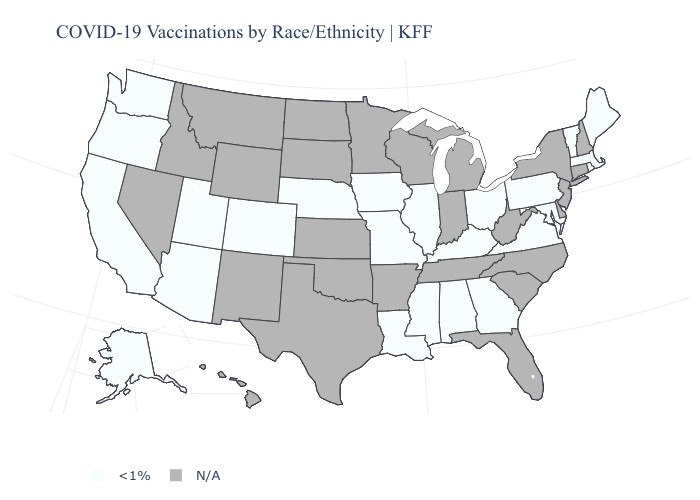Does the first symbol in the legend represent the smallest category?
Write a very short answer. Yes. What is the value of California?
Quick response, please. <1%. Name the states that have a value in the range N/A?
Keep it brief. Arkansas, Connecticut, Delaware, Florida, Hawaii, Idaho, Indiana, Kansas, Michigan, Minnesota, Montana, Nevada, New Hampshire, New Jersey, New Mexico, New York, North Carolina, North Dakota, Oklahoma, South Carolina, South Dakota, Tennessee, Texas, West Virginia, Wisconsin, Wyoming. What is the value of Virginia?
Short answer required. <1%. What is the lowest value in states that border Georgia?
Keep it brief. <1%. Name the states that have a value in the range N/A?
Write a very short answer. Arkansas, Connecticut, Delaware, Florida, Hawaii, Idaho, Indiana, Kansas, Michigan, Minnesota, Montana, Nevada, New Hampshire, New Jersey, New Mexico, New York, North Carolina, North Dakota, Oklahoma, South Carolina, South Dakota, Tennessee, Texas, West Virginia, Wisconsin, Wyoming. Which states hav the highest value in the South?
Give a very brief answer. Alabama, Georgia, Kentucky, Louisiana, Maryland, Mississippi, Virginia. What is the lowest value in the USA?
Keep it brief. <1%. What is the highest value in states that border New Mexico?
Answer briefly. <1%. Name the states that have a value in the range <1%?
Keep it brief. Alabama, Alaska, Arizona, California, Colorado, Georgia, Illinois, Iowa, Kentucky, Louisiana, Maine, Maryland, Massachusetts, Mississippi, Missouri, Nebraska, Ohio, Oregon, Pennsylvania, Rhode Island, Utah, Vermont, Virginia, Washington. 